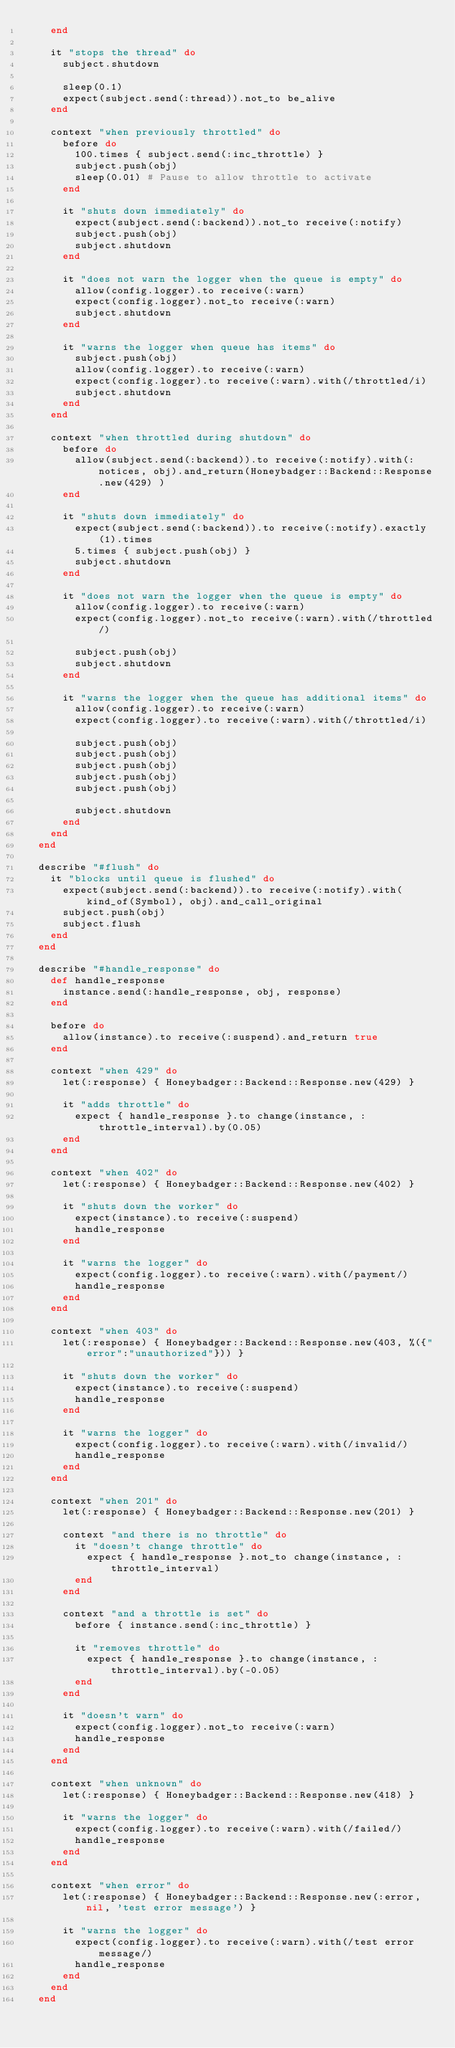Convert code to text. <code><loc_0><loc_0><loc_500><loc_500><_Ruby_>    end

    it "stops the thread" do
      subject.shutdown

      sleep(0.1)
      expect(subject.send(:thread)).not_to be_alive
    end

    context "when previously throttled" do
      before do
        100.times { subject.send(:inc_throttle) }
        subject.push(obj)
        sleep(0.01) # Pause to allow throttle to activate
      end

      it "shuts down immediately" do
        expect(subject.send(:backend)).not_to receive(:notify)
        subject.push(obj)
        subject.shutdown
      end

      it "does not warn the logger when the queue is empty" do
        allow(config.logger).to receive(:warn)
        expect(config.logger).not_to receive(:warn)
        subject.shutdown
      end

      it "warns the logger when queue has items" do
        subject.push(obj)
        allow(config.logger).to receive(:warn)
        expect(config.logger).to receive(:warn).with(/throttled/i)
        subject.shutdown
      end
    end

    context "when throttled during shutdown" do
      before do
        allow(subject.send(:backend)).to receive(:notify).with(:notices, obj).and_return(Honeybadger::Backend::Response.new(429) )
      end

      it "shuts down immediately" do
        expect(subject.send(:backend)).to receive(:notify).exactly(1).times
        5.times { subject.push(obj) }
        subject.shutdown
      end

      it "does not warn the logger when the queue is empty" do
        allow(config.logger).to receive(:warn)
        expect(config.logger).not_to receive(:warn).with(/throttled/)

        subject.push(obj)
        subject.shutdown
      end

      it "warns the logger when the queue has additional items" do
        allow(config.logger).to receive(:warn)
        expect(config.logger).to receive(:warn).with(/throttled/i)

        subject.push(obj)
        subject.push(obj)
        subject.push(obj)
        subject.push(obj)
        subject.push(obj)

        subject.shutdown
      end
    end
  end

  describe "#flush" do
    it "blocks until queue is flushed" do
      expect(subject.send(:backend)).to receive(:notify).with(kind_of(Symbol), obj).and_call_original
      subject.push(obj)
      subject.flush
    end
  end

  describe "#handle_response" do
    def handle_response
      instance.send(:handle_response, obj, response)
    end

    before do
      allow(instance).to receive(:suspend).and_return true
    end

    context "when 429" do
      let(:response) { Honeybadger::Backend::Response.new(429) }

      it "adds throttle" do
        expect { handle_response }.to change(instance, :throttle_interval).by(0.05)
      end
    end

    context "when 402" do
      let(:response) { Honeybadger::Backend::Response.new(402) }

      it "shuts down the worker" do
        expect(instance).to receive(:suspend)
        handle_response
      end

      it "warns the logger" do
        expect(config.logger).to receive(:warn).with(/payment/)
        handle_response
      end
    end

    context "when 403" do
      let(:response) { Honeybadger::Backend::Response.new(403, %({"error":"unauthorized"})) }

      it "shuts down the worker" do
        expect(instance).to receive(:suspend)
        handle_response
      end

      it "warns the logger" do
        expect(config.logger).to receive(:warn).with(/invalid/)
        handle_response
      end
    end

    context "when 201" do
      let(:response) { Honeybadger::Backend::Response.new(201) }

      context "and there is no throttle" do
        it "doesn't change throttle" do
          expect { handle_response }.not_to change(instance, :throttle_interval)
        end
      end

      context "and a throttle is set" do
        before { instance.send(:inc_throttle) }

        it "removes throttle" do
          expect { handle_response }.to change(instance, :throttle_interval).by(-0.05)
        end
      end

      it "doesn't warn" do
        expect(config.logger).not_to receive(:warn)
        handle_response
      end
    end

    context "when unknown" do
      let(:response) { Honeybadger::Backend::Response.new(418) }

      it "warns the logger" do
        expect(config.logger).to receive(:warn).with(/failed/)
        handle_response
      end
    end

    context "when error" do
      let(:response) { Honeybadger::Backend::Response.new(:error, nil, 'test error message') }

      it "warns the logger" do
        expect(config.logger).to receive(:warn).with(/test error message/)
        handle_response
      end
    end
  end</code> 